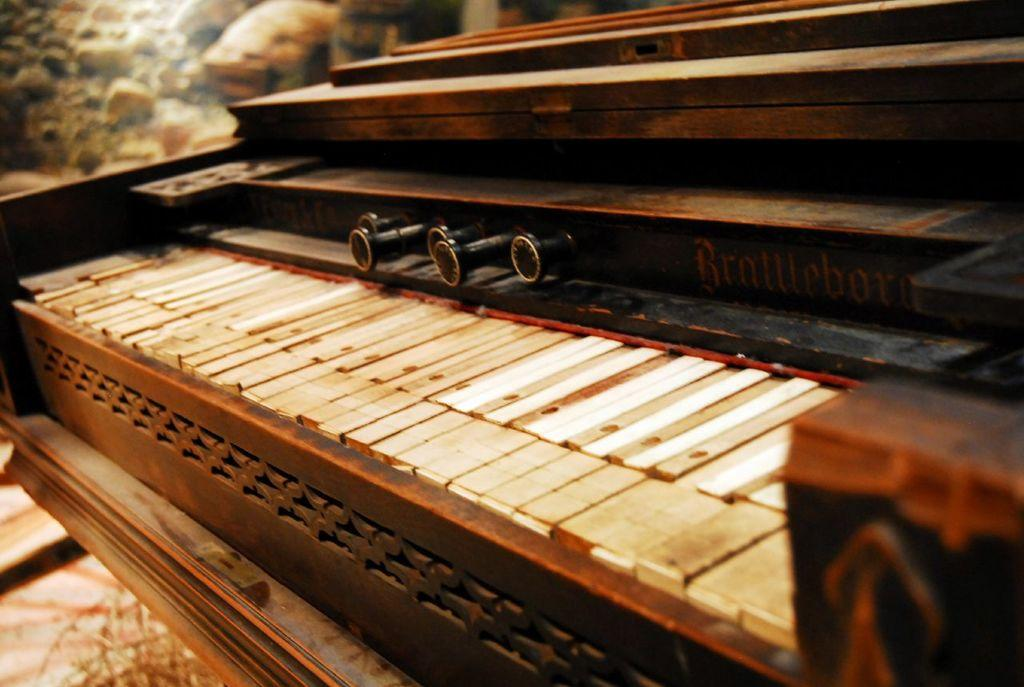What is the main object in the image? There is a piano in the image. Where is the mailbox located in the image? There is no mailbox present in the image. Can you see anyone walking or playing the piano in the image? The image does not show anyone walking or playing the piano. Is there a plane visible in the image? There is no plane present in the image. 